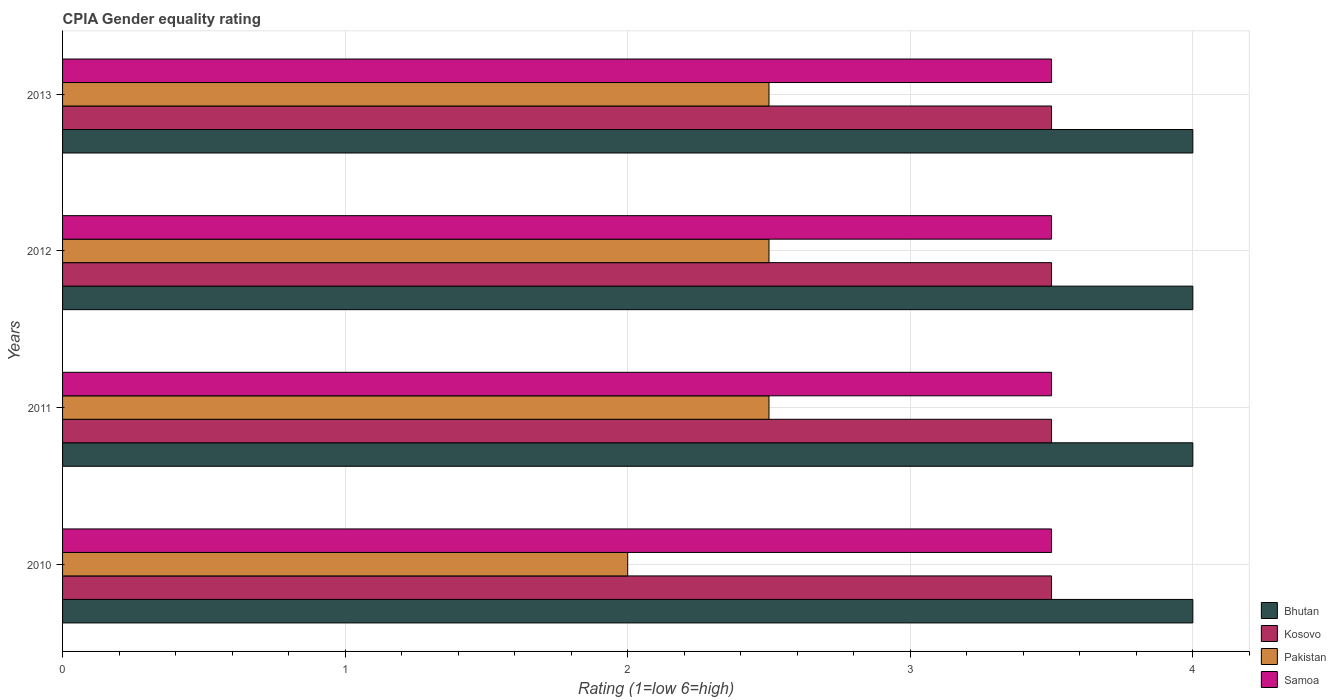How many groups of bars are there?
Keep it short and to the point. 4. Are the number of bars per tick equal to the number of legend labels?
Provide a succinct answer. Yes. Are the number of bars on each tick of the Y-axis equal?
Offer a terse response. Yes. How many bars are there on the 3rd tick from the top?
Ensure brevity in your answer.  4. What is the label of the 4th group of bars from the top?
Your response must be concise. 2010. What is the CPIA rating in Bhutan in 2012?
Offer a very short reply. 4. Across all years, what is the maximum CPIA rating in Bhutan?
Give a very brief answer. 4. Across all years, what is the minimum CPIA rating in Pakistan?
Provide a short and direct response. 2. What is the difference between the CPIA rating in Bhutan in 2011 and the CPIA rating in Kosovo in 2012?
Ensure brevity in your answer.  0.5. In the year 2012, what is the difference between the CPIA rating in Bhutan and CPIA rating in Samoa?
Provide a succinct answer. 0.5. In how many years, is the CPIA rating in Pakistan greater than 0.6000000000000001 ?
Provide a succinct answer. 4. What is the ratio of the CPIA rating in Pakistan in 2011 to that in 2012?
Make the answer very short. 1. In how many years, is the CPIA rating in Pakistan greater than the average CPIA rating in Pakistan taken over all years?
Provide a succinct answer. 3. Is the sum of the CPIA rating in Pakistan in 2011 and 2013 greater than the maximum CPIA rating in Samoa across all years?
Keep it short and to the point. Yes. Is it the case that in every year, the sum of the CPIA rating in Bhutan and CPIA rating in Samoa is greater than the sum of CPIA rating in Kosovo and CPIA rating in Pakistan?
Keep it short and to the point. Yes. What does the 2nd bar from the top in 2013 represents?
Give a very brief answer. Pakistan. Is it the case that in every year, the sum of the CPIA rating in Pakistan and CPIA rating in Kosovo is greater than the CPIA rating in Bhutan?
Offer a very short reply. Yes. How many years are there in the graph?
Your answer should be compact. 4. What is the difference between two consecutive major ticks on the X-axis?
Your response must be concise. 1. Does the graph contain any zero values?
Make the answer very short. No. Does the graph contain grids?
Offer a very short reply. Yes. How many legend labels are there?
Make the answer very short. 4. What is the title of the graph?
Provide a succinct answer. CPIA Gender equality rating. Does "Korea (Republic)" appear as one of the legend labels in the graph?
Your answer should be very brief. No. What is the Rating (1=low 6=high) in Samoa in 2011?
Keep it short and to the point. 3.5. What is the Rating (1=low 6=high) in Bhutan in 2012?
Offer a very short reply. 4. What is the Rating (1=low 6=high) in Bhutan in 2013?
Give a very brief answer. 4. What is the Rating (1=low 6=high) of Kosovo in 2013?
Keep it short and to the point. 3.5. Across all years, what is the maximum Rating (1=low 6=high) in Kosovo?
Offer a terse response. 3.5. Across all years, what is the maximum Rating (1=low 6=high) in Pakistan?
Ensure brevity in your answer.  2.5. What is the total Rating (1=low 6=high) of Bhutan in the graph?
Give a very brief answer. 16. What is the total Rating (1=low 6=high) of Kosovo in the graph?
Ensure brevity in your answer.  14. What is the total Rating (1=low 6=high) in Pakistan in the graph?
Keep it short and to the point. 9.5. What is the total Rating (1=low 6=high) of Samoa in the graph?
Your answer should be very brief. 14. What is the difference between the Rating (1=low 6=high) in Kosovo in 2010 and that in 2011?
Give a very brief answer. 0. What is the difference between the Rating (1=low 6=high) of Pakistan in 2010 and that in 2012?
Your response must be concise. -0.5. What is the difference between the Rating (1=low 6=high) of Samoa in 2010 and that in 2012?
Provide a short and direct response. 0. What is the difference between the Rating (1=low 6=high) of Bhutan in 2010 and that in 2013?
Provide a short and direct response. 0. What is the difference between the Rating (1=low 6=high) of Pakistan in 2010 and that in 2013?
Your answer should be very brief. -0.5. What is the difference between the Rating (1=low 6=high) in Kosovo in 2011 and that in 2012?
Give a very brief answer. 0. What is the difference between the Rating (1=low 6=high) in Pakistan in 2011 and that in 2012?
Offer a very short reply. 0. What is the difference between the Rating (1=low 6=high) of Kosovo in 2011 and that in 2013?
Provide a short and direct response. 0. What is the difference between the Rating (1=low 6=high) of Samoa in 2011 and that in 2013?
Make the answer very short. 0. What is the difference between the Rating (1=low 6=high) of Bhutan in 2012 and that in 2013?
Offer a terse response. 0. What is the difference between the Rating (1=low 6=high) in Kosovo in 2012 and that in 2013?
Give a very brief answer. 0. What is the difference between the Rating (1=low 6=high) of Bhutan in 2010 and the Rating (1=low 6=high) of Pakistan in 2011?
Make the answer very short. 1.5. What is the difference between the Rating (1=low 6=high) in Bhutan in 2010 and the Rating (1=low 6=high) in Samoa in 2011?
Give a very brief answer. 0.5. What is the difference between the Rating (1=low 6=high) in Kosovo in 2010 and the Rating (1=low 6=high) in Pakistan in 2011?
Keep it short and to the point. 1. What is the difference between the Rating (1=low 6=high) of Pakistan in 2010 and the Rating (1=low 6=high) of Samoa in 2011?
Make the answer very short. -1.5. What is the difference between the Rating (1=low 6=high) of Kosovo in 2010 and the Rating (1=low 6=high) of Samoa in 2012?
Ensure brevity in your answer.  0. What is the difference between the Rating (1=low 6=high) in Bhutan in 2010 and the Rating (1=low 6=high) in Samoa in 2013?
Offer a very short reply. 0.5. What is the difference between the Rating (1=low 6=high) in Kosovo in 2010 and the Rating (1=low 6=high) in Pakistan in 2013?
Keep it short and to the point. 1. What is the difference between the Rating (1=low 6=high) of Kosovo in 2010 and the Rating (1=low 6=high) of Samoa in 2013?
Make the answer very short. 0. What is the difference between the Rating (1=low 6=high) in Pakistan in 2010 and the Rating (1=low 6=high) in Samoa in 2013?
Ensure brevity in your answer.  -1.5. What is the difference between the Rating (1=low 6=high) in Bhutan in 2011 and the Rating (1=low 6=high) in Pakistan in 2012?
Offer a very short reply. 1.5. What is the difference between the Rating (1=low 6=high) of Bhutan in 2011 and the Rating (1=low 6=high) of Samoa in 2012?
Your answer should be compact. 0.5. What is the difference between the Rating (1=low 6=high) in Kosovo in 2011 and the Rating (1=low 6=high) in Samoa in 2012?
Keep it short and to the point. 0. What is the difference between the Rating (1=low 6=high) of Bhutan in 2011 and the Rating (1=low 6=high) of Kosovo in 2013?
Your answer should be very brief. 0.5. What is the difference between the Rating (1=low 6=high) in Bhutan in 2011 and the Rating (1=low 6=high) in Samoa in 2013?
Give a very brief answer. 0.5. What is the difference between the Rating (1=low 6=high) of Kosovo in 2011 and the Rating (1=low 6=high) of Pakistan in 2013?
Offer a very short reply. 1. What is the difference between the Rating (1=low 6=high) of Kosovo in 2011 and the Rating (1=low 6=high) of Samoa in 2013?
Provide a short and direct response. 0. What is the difference between the Rating (1=low 6=high) in Pakistan in 2011 and the Rating (1=low 6=high) in Samoa in 2013?
Offer a very short reply. -1. What is the difference between the Rating (1=low 6=high) in Bhutan in 2012 and the Rating (1=low 6=high) in Pakistan in 2013?
Offer a very short reply. 1.5. What is the difference between the Rating (1=low 6=high) in Kosovo in 2012 and the Rating (1=low 6=high) in Pakistan in 2013?
Provide a short and direct response. 1. What is the difference between the Rating (1=low 6=high) in Pakistan in 2012 and the Rating (1=low 6=high) in Samoa in 2013?
Provide a short and direct response. -1. What is the average Rating (1=low 6=high) of Pakistan per year?
Ensure brevity in your answer.  2.38. In the year 2010, what is the difference between the Rating (1=low 6=high) in Bhutan and Rating (1=low 6=high) in Kosovo?
Offer a very short reply. 0.5. In the year 2010, what is the difference between the Rating (1=low 6=high) of Bhutan and Rating (1=low 6=high) of Samoa?
Provide a short and direct response. 0.5. In the year 2010, what is the difference between the Rating (1=low 6=high) in Kosovo and Rating (1=low 6=high) in Samoa?
Make the answer very short. 0. In the year 2010, what is the difference between the Rating (1=low 6=high) in Pakistan and Rating (1=low 6=high) in Samoa?
Ensure brevity in your answer.  -1.5. In the year 2011, what is the difference between the Rating (1=low 6=high) of Bhutan and Rating (1=low 6=high) of Kosovo?
Give a very brief answer. 0.5. In the year 2011, what is the difference between the Rating (1=low 6=high) in Bhutan and Rating (1=low 6=high) in Pakistan?
Your answer should be very brief. 1.5. In the year 2011, what is the difference between the Rating (1=low 6=high) in Bhutan and Rating (1=low 6=high) in Samoa?
Your answer should be compact. 0.5. In the year 2011, what is the difference between the Rating (1=low 6=high) in Pakistan and Rating (1=low 6=high) in Samoa?
Your response must be concise. -1. In the year 2012, what is the difference between the Rating (1=low 6=high) in Bhutan and Rating (1=low 6=high) in Pakistan?
Offer a terse response. 1.5. In the year 2012, what is the difference between the Rating (1=low 6=high) of Bhutan and Rating (1=low 6=high) of Samoa?
Keep it short and to the point. 0.5. In the year 2012, what is the difference between the Rating (1=low 6=high) of Pakistan and Rating (1=low 6=high) of Samoa?
Provide a short and direct response. -1. In the year 2013, what is the difference between the Rating (1=low 6=high) of Bhutan and Rating (1=low 6=high) of Kosovo?
Make the answer very short. 0.5. In the year 2013, what is the difference between the Rating (1=low 6=high) of Bhutan and Rating (1=low 6=high) of Samoa?
Keep it short and to the point. 0.5. In the year 2013, what is the difference between the Rating (1=low 6=high) in Kosovo and Rating (1=low 6=high) in Pakistan?
Offer a terse response. 1. In the year 2013, what is the difference between the Rating (1=low 6=high) of Kosovo and Rating (1=low 6=high) of Samoa?
Offer a terse response. 0. In the year 2013, what is the difference between the Rating (1=low 6=high) of Pakistan and Rating (1=low 6=high) of Samoa?
Keep it short and to the point. -1. What is the ratio of the Rating (1=low 6=high) of Kosovo in 2010 to that in 2011?
Keep it short and to the point. 1. What is the ratio of the Rating (1=low 6=high) of Pakistan in 2010 to that in 2011?
Your response must be concise. 0.8. What is the ratio of the Rating (1=low 6=high) of Samoa in 2010 to that in 2011?
Keep it short and to the point. 1. What is the ratio of the Rating (1=low 6=high) in Bhutan in 2010 to that in 2012?
Provide a short and direct response. 1. What is the ratio of the Rating (1=low 6=high) of Pakistan in 2010 to that in 2012?
Your answer should be compact. 0.8. What is the ratio of the Rating (1=low 6=high) of Samoa in 2010 to that in 2012?
Offer a very short reply. 1. What is the ratio of the Rating (1=low 6=high) of Kosovo in 2011 to that in 2013?
Make the answer very short. 1. What is the ratio of the Rating (1=low 6=high) in Pakistan in 2011 to that in 2013?
Provide a short and direct response. 1. What is the ratio of the Rating (1=low 6=high) in Samoa in 2011 to that in 2013?
Keep it short and to the point. 1. What is the difference between the highest and the second highest Rating (1=low 6=high) of Bhutan?
Offer a terse response. 0. What is the difference between the highest and the second highest Rating (1=low 6=high) of Kosovo?
Give a very brief answer. 0. What is the difference between the highest and the second highest Rating (1=low 6=high) in Pakistan?
Provide a succinct answer. 0. What is the difference between the highest and the second highest Rating (1=low 6=high) of Samoa?
Provide a short and direct response. 0. What is the difference between the highest and the lowest Rating (1=low 6=high) of Bhutan?
Provide a short and direct response. 0. What is the difference between the highest and the lowest Rating (1=low 6=high) of Pakistan?
Offer a terse response. 0.5. What is the difference between the highest and the lowest Rating (1=low 6=high) of Samoa?
Offer a very short reply. 0. 